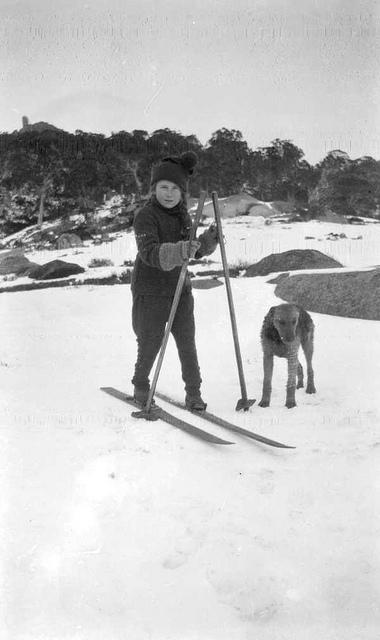How many canines are in the photo?
Answer briefly. 1. What color is the photo?
Write a very short answer. Black and white. How many dogs are in the photo?
Write a very short answer. 1. What is the man in the water doing?
Concise answer only. Skiing. What season is this?
Answer briefly. Winter. 